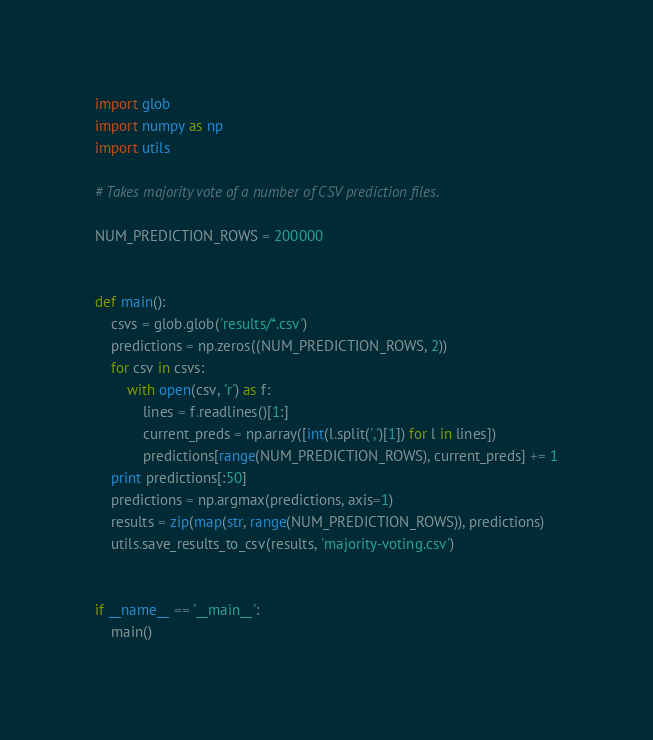Convert code to text. <code><loc_0><loc_0><loc_500><loc_500><_Python_>import glob
import numpy as np
import utils

# Takes majority vote of a number of CSV prediction files.

NUM_PREDICTION_ROWS = 200000


def main():
    csvs = glob.glob('results/*.csv')
    predictions = np.zeros((NUM_PREDICTION_ROWS, 2))
    for csv in csvs:
        with open(csv, 'r') as f:
            lines = f.readlines()[1:]
            current_preds = np.array([int(l.split(',')[1]) for l in lines])
            predictions[range(NUM_PREDICTION_ROWS), current_preds] += 1
    print predictions[:50]
    predictions = np.argmax(predictions, axis=1)
    results = zip(map(str, range(NUM_PREDICTION_ROWS)), predictions)
    utils.save_results_to_csv(results, 'majority-voting.csv')


if __name__ == '__main__':
    main()
</code> 